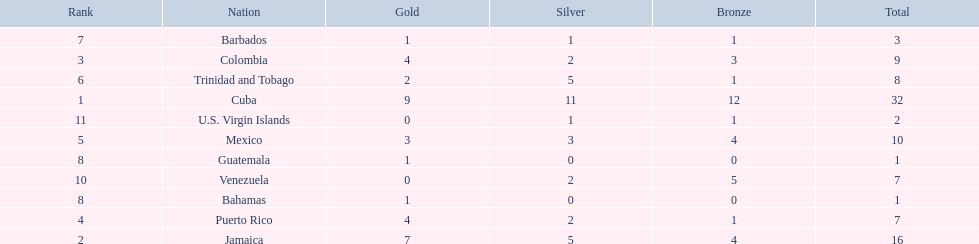Which teams have at exactly 4 gold medals? Colombia, Puerto Rico. Of those teams which has exactly 1 bronze medal? Puerto Rico. 